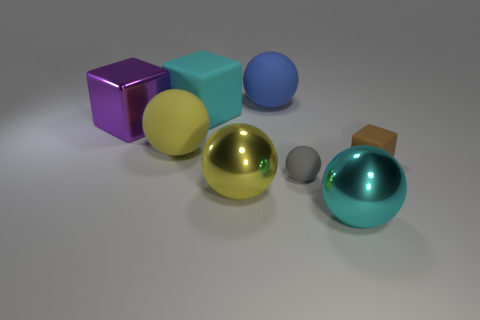Subtract 2 cubes. How many cubes are left? 1 Add 1 green things. How many objects exist? 9 Subtract all shiny spheres. How many spheres are left? 3 Add 6 large rubber balls. How many large rubber balls exist? 8 Subtract all cyan balls. How many balls are left? 4 Subtract 0 yellow blocks. How many objects are left? 8 Subtract all spheres. How many objects are left? 3 Subtract all green spheres. Subtract all gray cylinders. How many spheres are left? 5 Subtract all cyan cylinders. How many cyan balls are left? 1 Subtract all rubber blocks. Subtract all brown matte cubes. How many objects are left? 5 